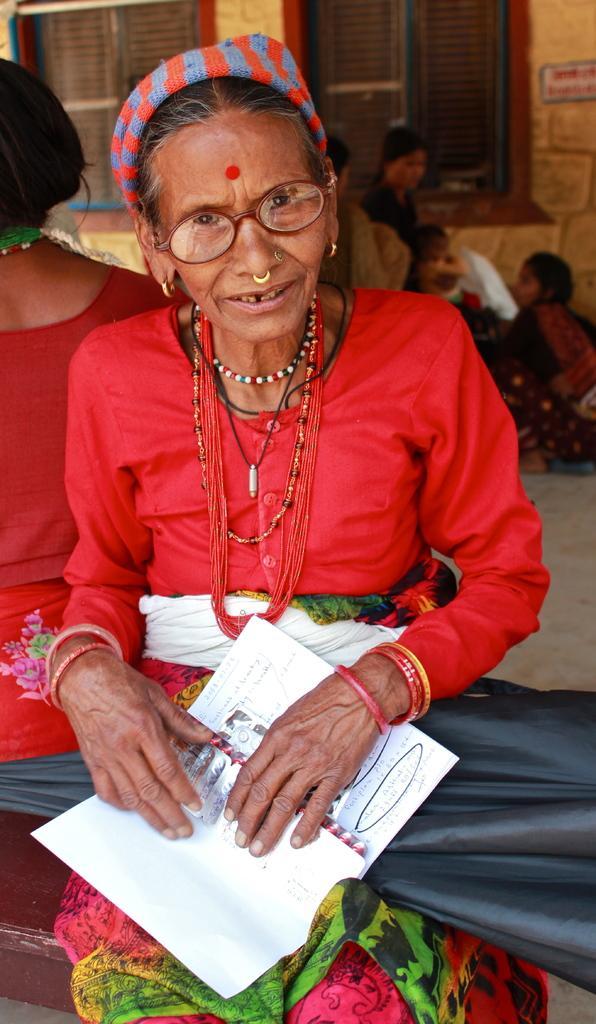Could you give a brief overview of what you see in this image? In this picture there is an old woman who is holding a book, behind her there is another woman who is sitting on the floor. In the back I can see some people who are standing near to the windows and wall. 